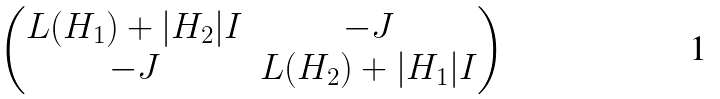Convert formula to latex. <formula><loc_0><loc_0><loc_500><loc_500>\begin{pmatrix} L ( H _ { 1 } ) + | H _ { 2 } | I & - J \\ - J & L ( H _ { 2 } ) + | H _ { 1 } | I \end{pmatrix}</formula> 